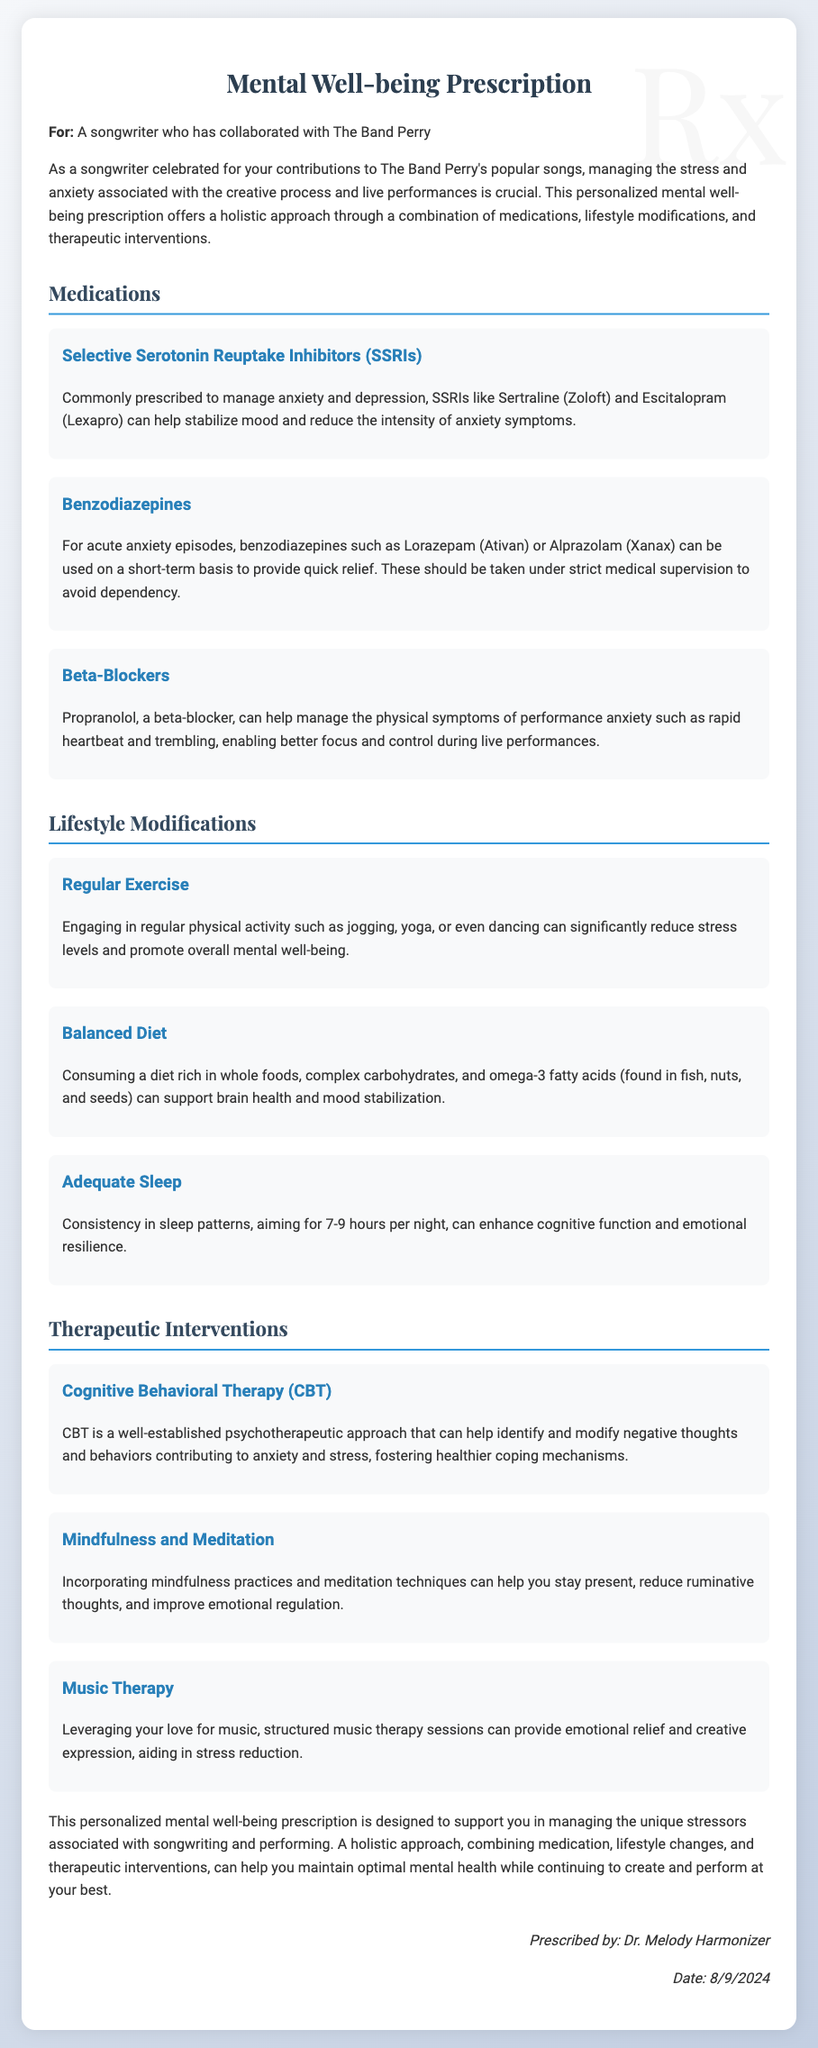what is the title of the document? The title of the document is prominently displayed at the top.
Answer: Mental Well-being Prescription who is the prescription for? The document specifies the individual for whom the prescription is intended.
Answer: A songwriter who has collaborated with The Band Perry name one medication recommended for managing anxiety. The prescription mentions various medications to manage anxiety, one of which is highlighted.
Answer: Sertraline (Zoloft) what physical symptom does Propranolol help manage? The document describes the purpose of Propranolol in relation to performance anxiety.
Answer: Rapid heartbeat how many hours of sleep are recommended per night? The document provides a specific recommendation for sleep duration.
Answer: 7-9 hours which therapeutic approach is mentioned for modifying negative thoughts? The document lists therapies that aid in managing anxiety; one specific approach is highlighted.
Answer: Cognitive Behavioral Therapy (CBT) what lifestyle modification is suggested to promote overall mental well-being? The document discusses several lifestyle changes; one is listed as particularly beneficial.
Answer: Regular Exercise who prescribed the mental well-being measures? The signature at the bottom of the document indicates who prescribed the measures.
Answer: Dr. Melody Harmonizer what is the date of the prescription? The date is dynamically generated in the document based on when it's viewed.
Answer: (Today's Date) 